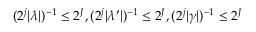<formula> <loc_0><loc_0><loc_500><loc_500>( 2 ^ { j } | \lambda | ) ^ { - 1 } \leq 2 ^ { J } , ( 2 ^ { j } | \lambda ^ { \prime } | ) ^ { - 1 } \leq 2 ^ { J } , ( 2 ^ { j } | \gamma | ) ^ { - 1 } \leq 2 ^ { J }</formula> 